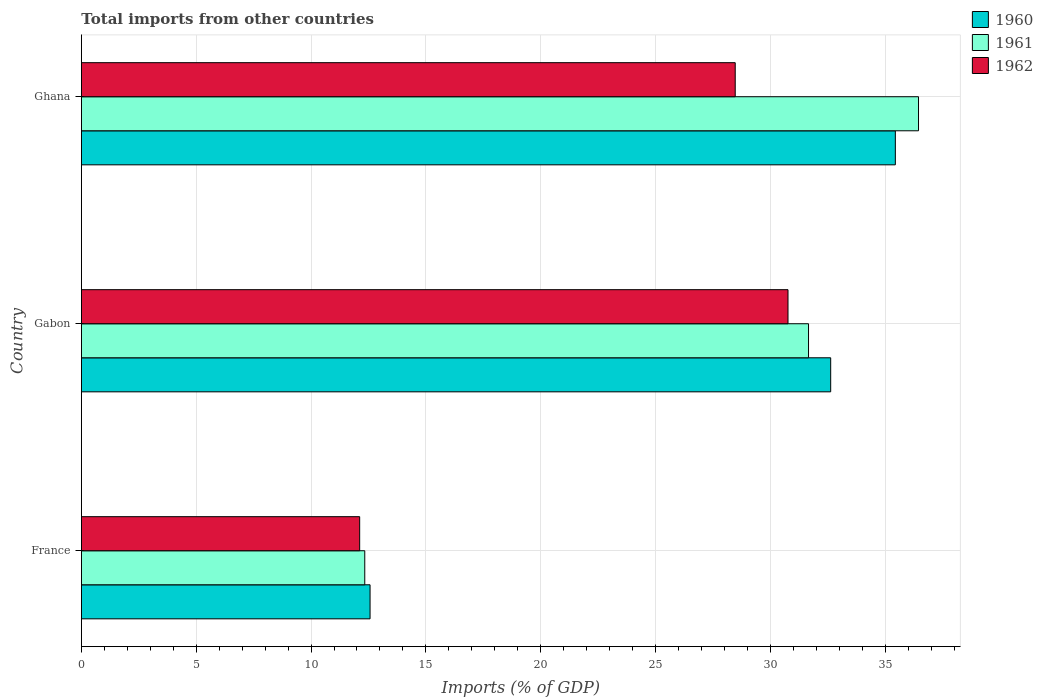How many different coloured bars are there?
Ensure brevity in your answer.  3. How many groups of bars are there?
Provide a short and direct response. 3. Are the number of bars per tick equal to the number of legend labels?
Offer a terse response. Yes. How many bars are there on the 2nd tick from the bottom?
Your response must be concise. 3. What is the label of the 3rd group of bars from the top?
Ensure brevity in your answer.  France. What is the total imports in 1962 in Gabon?
Provide a succinct answer. 30.77. Across all countries, what is the maximum total imports in 1960?
Offer a terse response. 35.44. Across all countries, what is the minimum total imports in 1962?
Your answer should be compact. 12.12. In which country was the total imports in 1960 minimum?
Provide a short and direct response. France. What is the total total imports in 1961 in the graph?
Offer a very short reply. 80.45. What is the difference between the total imports in 1960 in France and that in Ghana?
Offer a very short reply. -22.87. What is the difference between the total imports in 1962 in Ghana and the total imports in 1961 in France?
Your answer should be compact. 16.13. What is the average total imports in 1961 per country?
Your answer should be very brief. 26.82. What is the difference between the total imports in 1961 and total imports in 1962 in France?
Make the answer very short. 0.22. What is the ratio of the total imports in 1961 in France to that in Ghana?
Offer a very short reply. 0.34. Is the difference between the total imports in 1961 in France and Gabon greater than the difference between the total imports in 1962 in France and Gabon?
Ensure brevity in your answer.  No. What is the difference between the highest and the second highest total imports in 1960?
Provide a succinct answer. 2.82. What is the difference between the highest and the lowest total imports in 1961?
Offer a very short reply. 24.11. In how many countries, is the total imports in 1962 greater than the average total imports in 1962 taken over all countries?
Keep it short and to the point. 2. What does the 2nd bar from the bottom in Gabon represents?
Your answer should be very brief. 1961. How many bars are there?
Give a very brief answer. 9. Are all the bars in the graph horizontal?
Offer a very short reply. Yes. How many countries are there in the graph?
Ensure brevity in your answer.  3. Are the values on the major ticks of X-axis written in scientific E-notation?
Offer a very short reply. No. Does the graph contain any zero values?
Give a very brief answer. No. How many legend labels are there?
Your response must be concise. 3. What is the title of the graph?
Your answer should be very brief. Total imports from other countries. What is the label or title of the X-axis?
Make the answer very short. Imports (% of GDP). What is the label or title of the Y-axis?
Your answer should be very brief. Country. What is the Imports (% of GDP) in 1960 in France?
Your answer should be very brief. 12.57. What is the Imports (% of GDP) of 1961 in France?
Ensure brevity in your answer.  12.34. What is the Imports (% of GDP) of 1962 in France?
Your answer should be very brief. 12.12. What is the Imports (% of GDP) in 1960 in Gabon?
Your response must be concise. 32.63. What is the Imports (% of GDP) in 1961 in Gabon?
Your response must be concise. 31.66. What is the Imports (% of GDP) in 1962 in Gabon?
Ensure brevity in your answer.  30.77. What is the Imports (% of GDP) of 1960 in Ghana?
Keep it short and to the point. 35.44. What is the Imports (% of GDP) in 1961 in Ghana?
Ensure brevity in your answer.  36.45. What is the Imports (% of GDP) in 1962 in Ghana?
Give a very brief answer. 28.47. Across all countries, what is the maximum Imports (% of GDP) of 1960?
Your answer should be compact. 35.44. Across all countries, what is the maximum Imports (% of GDP) of 1961?
Ensure brevity in your answer.  36.45. Across all countries, what is the maximum Imports (% of GDP) of 1962?
Offer a very short reply. 30.77. Across all countries, what is the minimum Imports (% of GDP) of 1960?
Offer a very short reply. 12.57. Across all countries, what is the minimum Imports (% of GDP) of 1961?
Make the answer very short. 12.34. Across all countries, what is the minimum Imports (% of GDP) of 1962?
Keep it short and to the point. 12.12. What is the total Imports (% of GDP) in 1960 in the graph?
Ensure brevity in your answer.  80.64. What is the total Imports (% of GDP) in 1961 in the graph?
Offer a terse response. 80.45. What is the total Imports (% of GDP) of 1962 in the graph?
Offer a terse response. 71.36. What is the difference between the Imports (% of GDP) in 1960 in France and that in Gabon?
Keep it short and to the point. -20.06. What is the difference between the Imports (% of GDP) in 1961 in France and that in Gabon?
Provide a succinct answer. -19.32. What is the difference between the Imports (% of GDP) of 1962 in France and that in Gabon?
Provide a succinct answer. -18.65. What is the difference between the Imports (% of GDP) in 1960 in France and that in Ghana?
Provide a short and direct response. -22.87. What is the difference between the Imports (% of GDP) in 1961 in France and that in Ghana?
Offer a terse response. -24.11. What is the difference between the Imports (% of GDP) of 1962 in France and that in Ghana?
Keep it short and to the point. -16.35. What is the difference between the Imports (% of GDP) of 1960 in Gabon and that in Ghana?
Keep it short and to the point. -2.82. What is the difference between the Imports (% of GDP) in 1961 in Gabon and that in Ghana?
Your answer should be compact. -4.79. What is the difference between the Imports (% of GDP) in 1962 in Gabon and that in Ghana?
Ensure brevity in your answer.  2.3. What is the difference between the Imports (% of GDP) of 1960 in France and the Imports (% of GDP) of 1961 in Gabon?
Provide a short and direct response. -19.09. What is the difference between the Imports (% of GDP) in 1960 in France and the Imports (% of GDP) in 1962 in Gabon?
Your response must be concise. -18.2. What is the difference between the Imports (% of GDP) of 1961 in France and the Imports (% of GDP) of 1962 in Gabon?
Make the answer very short. -18.43. What is the difference between the Imports (% of GDP) in 1960 in France and the Imports (% of GDP) in 1961 in Ghana?
Ensure brevity in your answer.  -23.88. What is the difference between the Imports (% of GDP) of 1960 in France and the Imports (% of GDP) of 1962 in Ghana?
Give a very brief answer. -15.9. What is the difference between the Imports (% of GDP) of 1961 in France and the Imports (% of GDP) of 1962 in Ghana?
Give a very brief answer. -16.13. What is the difference between the Imports (% of GDP) in 1960 in Gabon and the Imports (% of GDP) in 1961 in Ghana?
Offer a very short reply. -3.82. What is the difference between the Imports (% of GDP) of 1960 in Gabon and the Imports (% of GDP) of 1962 in Ghana?
Give a very brief answer. 4.16. What is the difference between the Imports (% of GDP) in 1961 in Gabon and the Imports (% of GDP) in 1962 in Ghana?
Make the answer very short. 3.19. What is the average Imports (% of GDP) of 1960 per country?
Your response must be concise. 26.88. What is the average Imports (% of GDP) in 1961 per country?
Your response must be concise. 26.82. What is the average Imports (% of GDP) in 1962 per country?
Offer a terse response. 23.79. What is the difference between the Imports (% of GDP) of 1960 and Imports (% of GDP) of 1961 in France?
Your answer should be very brief. 0.23. What is the difference between the Imports (% of GDP) of 1960 and Imports (% of GDP) of 1962 in France?
Your answer should be very brief. 0.45. What is the difference between the Imports (% of GDP) of 1961 and Imports (% of GDP) of 1962 in France?
Your answer should be very brief. 0.22. What is the difference between the Imports (% of GDP) of 1960 and Imports (% of GDP) of 1961 in Gabon?
Give a very brief answer. 0.96. What is the difference between the Imports (% of GDP) in 1960 and Imports (% of GDP) in 1962 in Gabon?
Your answer should be very brief. 1.86. What is the difference between the Imports (% of GDP) in 1961 and Imports (% of GDP) in 1962 in Gabon?
Offer a very short reply. 0.89. What is the difference between the Imports (% of GDP) of 1960 and Imports (% of GDP) of 1961 in Ghana?
Provide a short and direct response. -1.01. What is the difference between the Imports (% of GDP) in 1960 and Imports (% of GDP) in 1962 in Ghana?
Provide a succinct answer. 6.97. What is the difference between the Imports (% of GDP) in 1961 and Imports (% of GDP) in 1962 in Ghana?
Your answer should be compact. 7.98. What is the ratio of the Imports (% of GDP) in 1960 in France to that in Gabon?
Offer a very short reply. 0.39. What is the ratio of the Imports (% of GDP) of 1961 in France to that in Gabon?
Provide a short and direct response. 0.39. What is the ratio of the Imports (% of GDP) of 1962 in France to that in Gabon?
Your response must be concise. 0.39. What is the ratio of the Imports (% of GDP) of 1960 in France to that in Ghana?
Offer a terse response. 0.35. What is the ratio of the Imports (% of GDP) in 1961 in France to that in Ghana?
Give a very brief answer. 0.34. What is the ratio of the Imports (% of GDP) of 1962 in France to that in Ghana?
Your answer should be very brief. 0.43. What is the ratio of the Imports (% of GDP) of 1960 in Gabon to that in Ghana?
Provide a succinct answer. 0.92. What is the ratio of the Imports (% of GDP) in 1961 in Gabon to that in Ghana?
Ensure brevity in your answer.  0.87. What is the ratio of the Imports (% of GDP) in 1962 in Gabon to that in Ghana?
Keep it short and to the point. 1.08. What is the difference between the highest and the second highest Imports (% of GDP) in 1960?
Give a very brief answer. 2.82. What is the difference between the highest and the second highest Imports (% of GDP) in 1961?
Offer a terse response. 4.79. What is the difference between the highest and the second highest Imports (% of GDP) of 1962?
Ensure brevity in your answer.  2.3. What is the difference between the highest and the lowest Imports (% of GDP) in 1960?
Give a very brief answer. 22.87. What is the difference between the highest and the lowest Imports (% of GDP) of 1961?
Provide a succinct answer. 24.11. What is the difference between the highest and the lowest Imports (% of GDP) in 1962?
Provide a succinct answer. 18.65. 